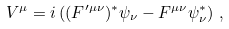<formula> <loc_0><loc_0><loc_500><loc_500>V ^ { \mu } = i \left ( ( F ^ { \prime \mu \nu } ) ^ { * } \psi _ { \nu } - F ^ { \mu \nu } \psi _ { \nu } ^ { * } \right ) \, ,</formula> 